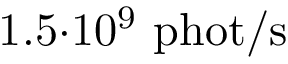Convert formula to latex. <formula><loc_0><loc_0><loc_500><loc_500>1 . 5 { \cdot } 1 0 ^ { 9 } \ p h o t / s</formula> 